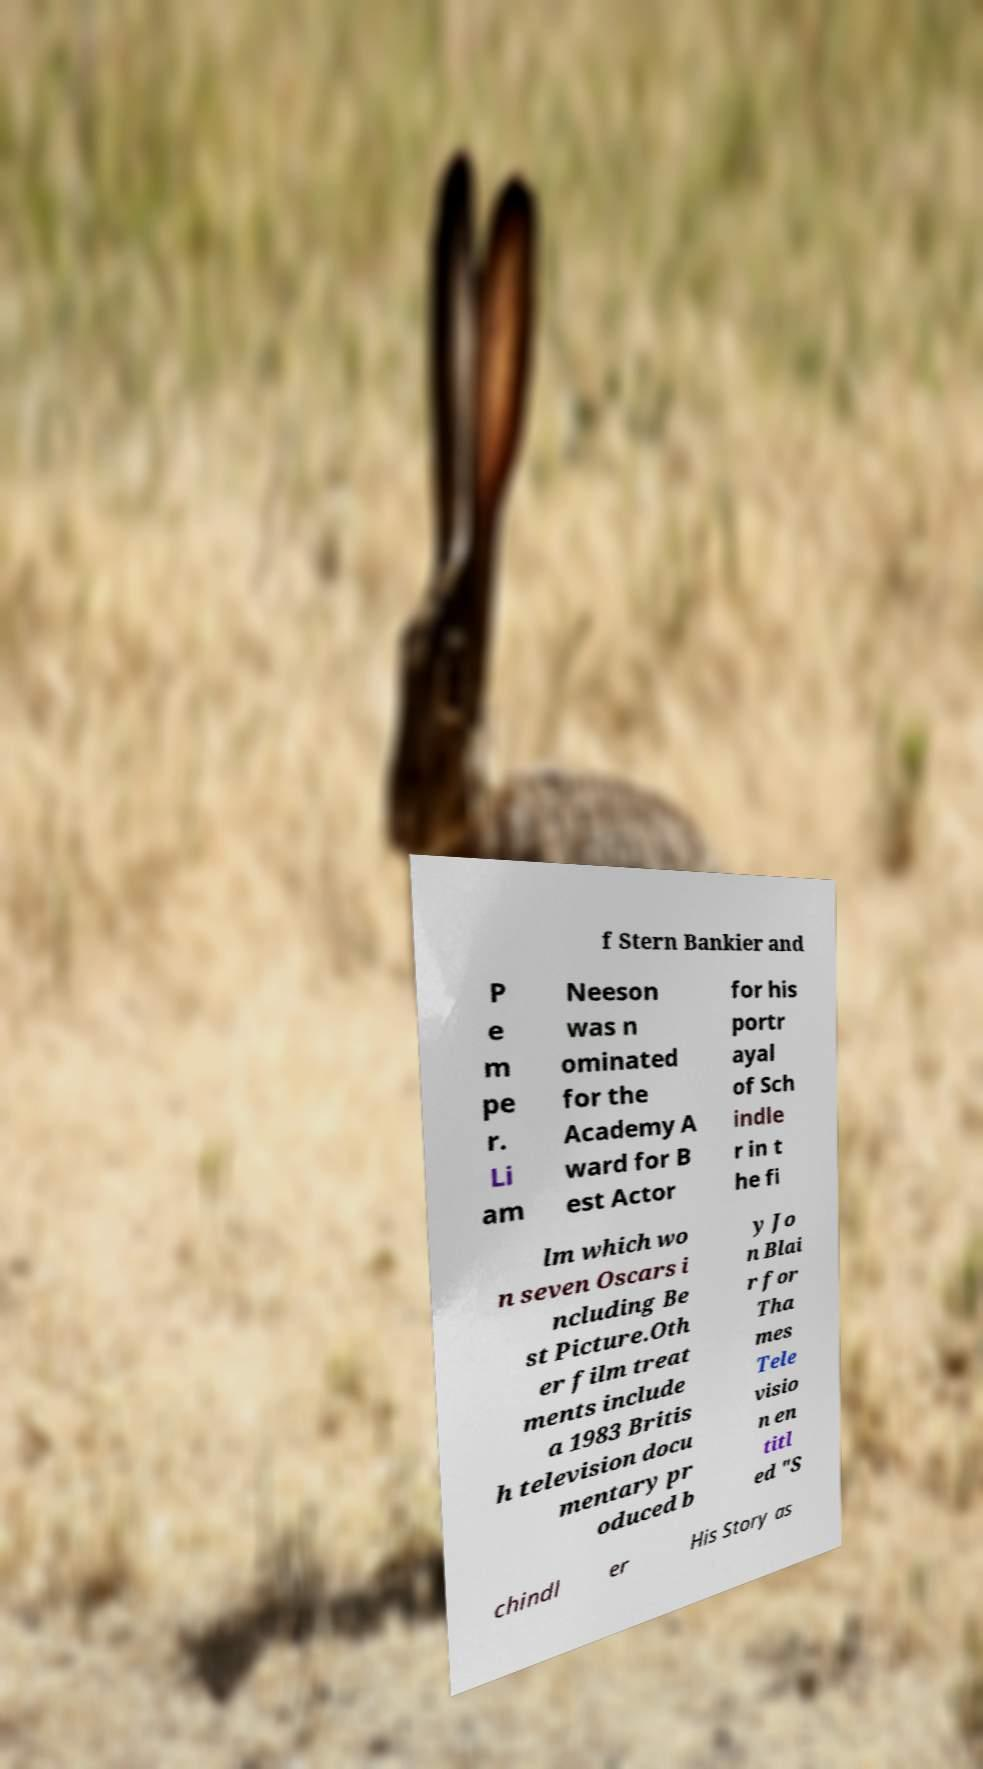Can you read and provide the text displayed in the image?This photo seems to have some interesting text. Can you extract and type it out for me? f Stern Bankier and P e m pe r. Li am Neeson was n ominated for the Academy A ward for B est Actor for his portr ayal of Sch indle r in t he fi lm which wo n seven Oscars i ncluding Be st Picture.Oth er film treat ments include a 1983 Britis h television docu mentary pr oduced b y Jo n Blai r for Tha mes Tele visio n en titl ed "S chindl er His Story as 